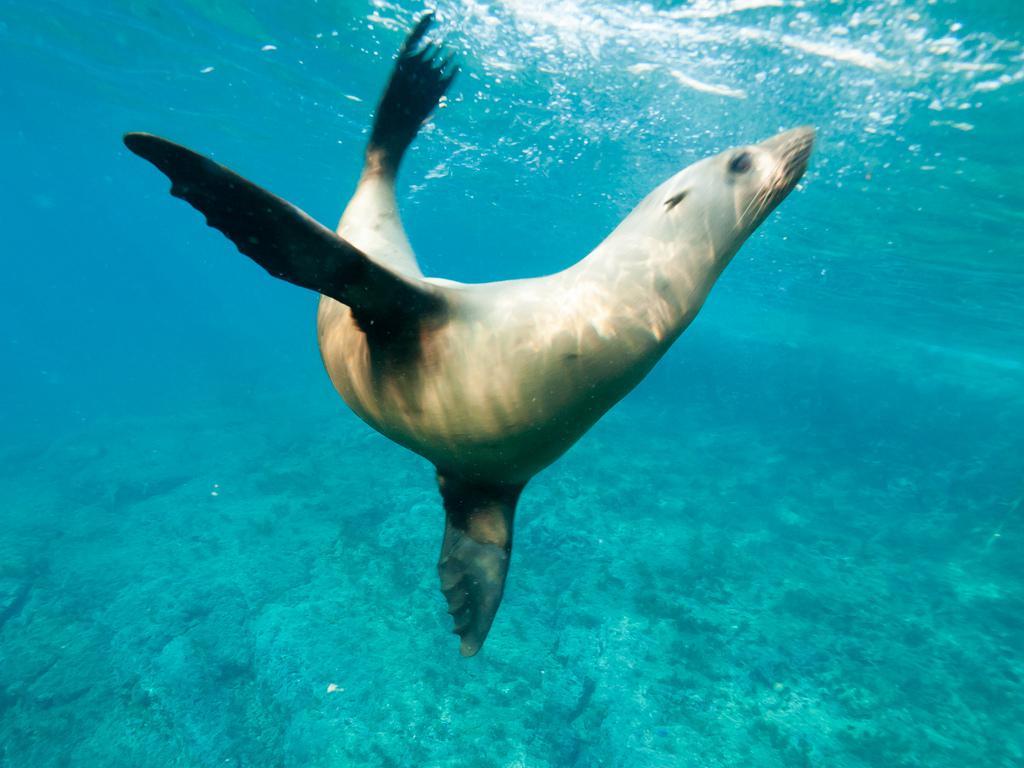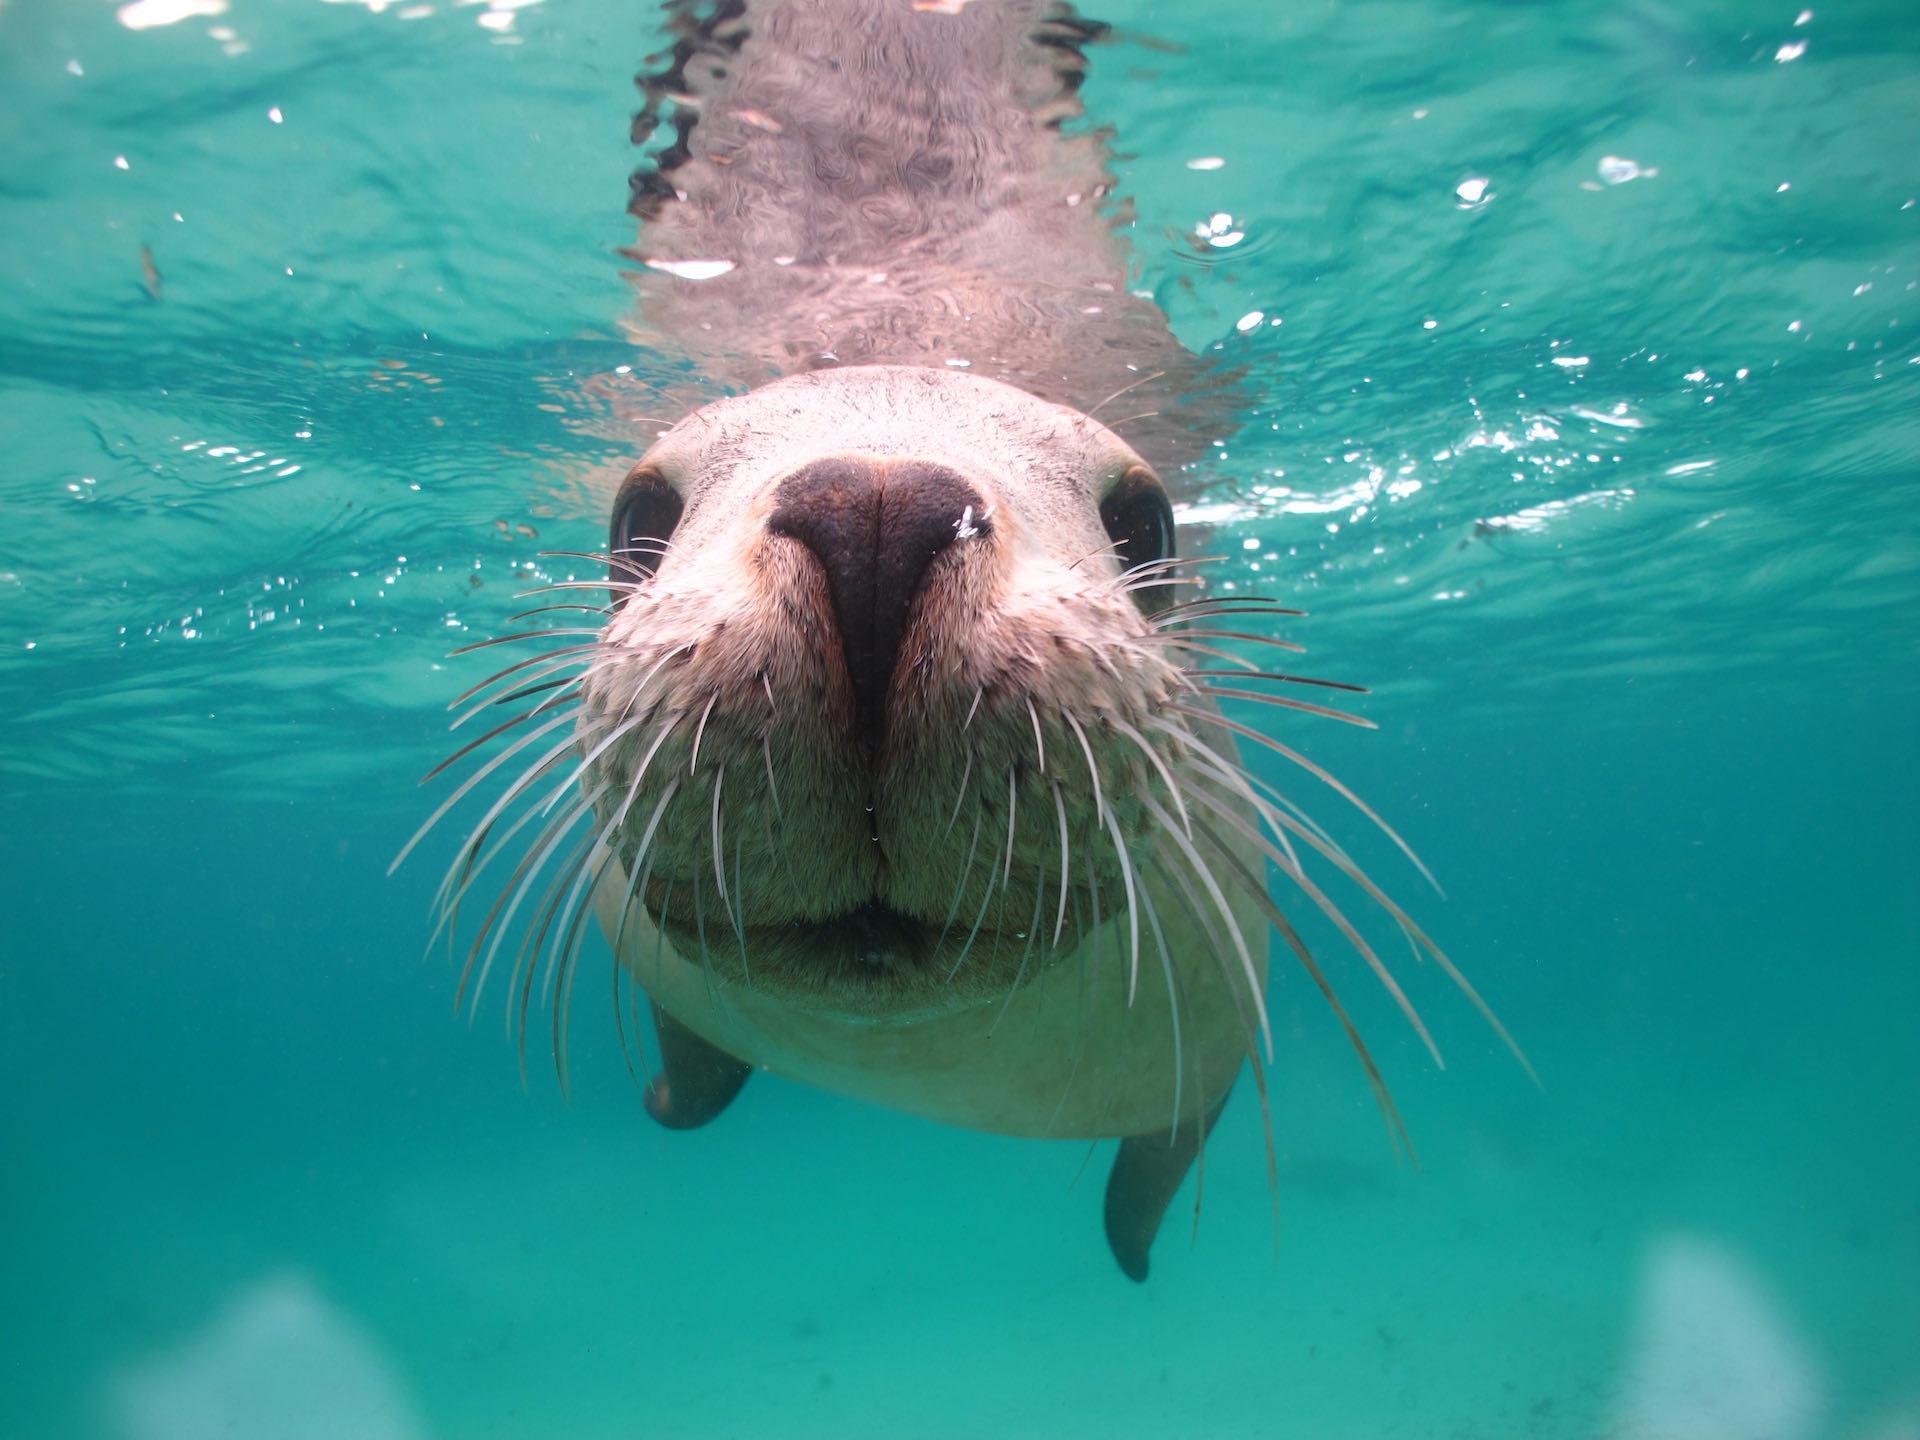The first image is the image on the left, the second image is the image on the right. For the images displayed, is the sentence "There are two seals swimming in the ocean." factually correct? Answer yes or no. Yes. The first image is the image on the left, the second image is the image on the right. For the images shown, is this caption "One of the seals are swimming UP towards the surface." true? Answer yes or no. Yes. 